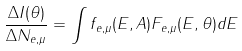Convert formula to latex. <formula><loc_0><loc_0><loc_500><loc_500>\frac { \Delta I ( \theta ) } { \Delta N _ { e , \mu } } = \int f _ { e , \mu } ( E , A ) F _ { e , \mu } ( E , \theta ) d E</formula> 